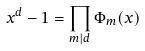<formula> <loc_0><loc_0><loc_500><loc_500>x ^ { d } - 1 = \prod _ { m | d } \Phi _ { m } ( x )</formula> 